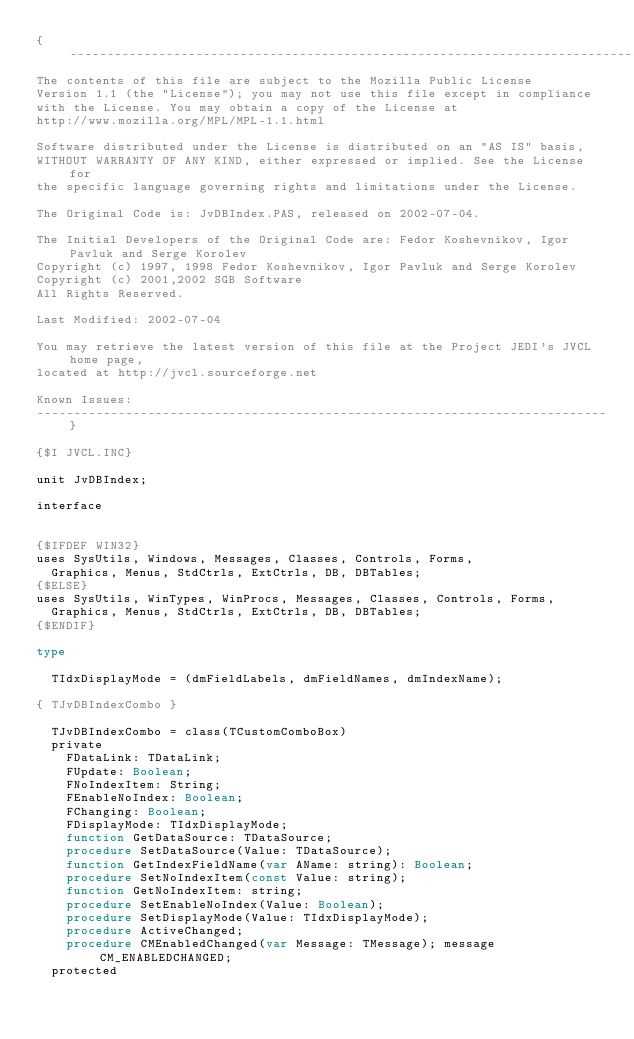<code> <loc_0><loc_0><loc_500><loc_500><_Pascal_>{-----------------------------------------------------------------------------
The contents of this file are subject to the Mozilla Public License
Version 1.1 (the "License"); you may not use this file except in compliance
with the License. You may obtain a copy of the License at
http://www.mozilla.org/MPL/MPL-1.1.html

Software distributed under the License is distributed on an "AS IS" basis,
WITHOUT WARRANTY OF ANY KIND, either expressed or implied. See the License for
the specific language governing rights and limitations under the License.

The Original Code is: JvDBIndex.PAS, released on 2002-07-04.

The Initial Developers of the Original Code are: Fedor Koshevnikov, Igor Pavluk and Serge Korolev
Copyright (c) 1997, 1998 Fedor Koshevnikov, Igor Pavluk and Serge Korolev
Copyright (c) 2001,2002 SGB Software          
All Rights Reserved.

Last Modified: 2002-07-04

You may retrieve the latest version of this file at the Project JEDI's JVCL home page,
located at http://jvcl.sourceforge.net

Known Issues:
-----------------------------------------------------------------------------}

{$I JVCL.INC}

unit JvDBIndex;

interface


{$IFDEF WIN32}
uses SysUtils, Windows, Messages, Classes, Controls, Forms,
  Graphics, Menus, StdCtrls, ExtCtrls, DB, DBTables;
{$ELSE}
uses SysUtils, WinTypes, WinProcs, Messages, Classes, Controls, Forms,
  Graphics, Menus, StdCtrls, ExtCtrls, DB, DBTables;
{$ENDIF}

type

  TIdxDisplayMode = (dmFieldLabels, dmFieldNames, dmIndexName);

{ TJvDBIndexCombo }

  TJvDBIndexCombo = class(TCustomComboBox)
  private
    FDataLink: TDataLink;
    FUpdate: Boolean;
    FNoIndexItem: String;
    FEnableNoIndex: Boolean;
    FChanging: Boolean;
    FDisplayMode: TIdxDisplayMode;
    function GetDataSource: TDataSource;
    procedure SetDataSource(Value: TDataSource);
    function GetIndexFieldName(var AName: string): Boolean;
    procedure SetNoIndexItem(const Value: string);
    function GetNoIndexItem: string;
    procedure SetEnableNoIndex(Value: Boolean);
    procedure SetDisplayMode(Value: TIdxDisplayMode);
    procedure ActiveChanged;
    procedure CMEnabledChanged(var Message: TMessage); message CM_ENABLEDCHANGED;
  protected</code> 